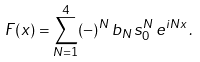<formula> <loc_0><loc_0><loc_500><loc_500>F ( x ) = \sum _ { N = 1 } ^ { 4 } ( - ) ^ { N } \, b _ { N } \, s _ { 0 } ^ { N } \, e ^ { i N x } \, .</formula> 